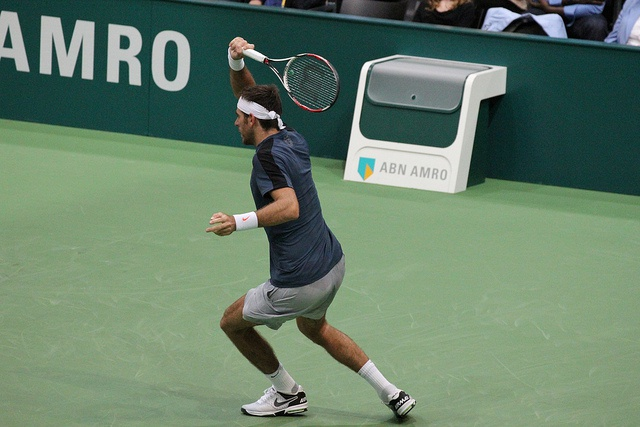Describe the objects in this image and their specific colors. I can see people in black, gray, and darkgray tones, tennis racket in black, gray, teal, and lightgray tones, and people in black, tan, and maroon tones in this image. 